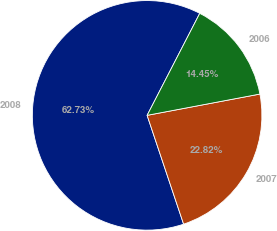Convert chart. <chart><loc_0><loc_0><loc_500><loc_500><pie_chart><fcel>2008<fcel>2007<fcel>2006<nl><fcel>62.73%<fcel>22.82%<fcel>14.45%<nl></chart> 